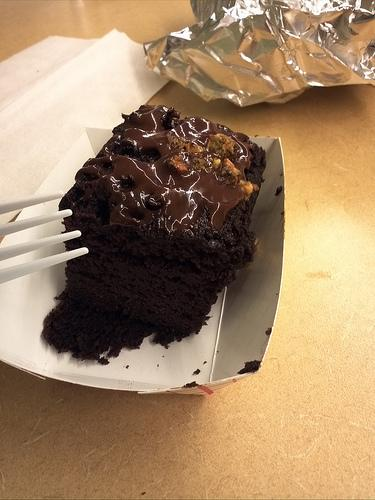What is the general sentiment or emotion that this image is likely to evoke in viewers? The image is likely to evoke feelings of indulgence, satisfaction, or temptation as the main focus is on a rich chocolate cake. Can you identify any materials used for the objects within this image? Yes, the fork is made of plastic, the dish is made of paper, and the crumpled object is made of aluminum foil. What is the main food item in the image? A piece of chocolate cake in a white paper dish. Explain the relationship between the objects near the chocolate cake. The objects near the chocolate cake, such as the white plastic fork, white napkin, and crumpled aluminum foil, are all items that are typically present during a casual dessert eating experience and complement the cake. Count the number of objects in the image that are made of plastic. There is only one plastic object, which is the white plastic fork. Is the presentation of the chocolate cake and its setting visually appealing? Explain your answer. Yes, the presentation is visually appealing with the chocolate cake as the main focus, surrounded by a clean fork, napkin, and crumpled aluminum foil that adds texture to the image. Describe any additional toppings or decorations present on the cake. There are nuts on top of the chocolate cake as a decorative and flavorful addition. Provide a brief description of the entire scene in the image. There is a piece of chocolate cake with nuts on a white paper dish next to a white plastic fork, crumpled aluminum foil, and white napkin on a beige countertop. Are there any inedible objects on the plate with the chocolate cake? No, there are no inedible objects on the plate with the chocolate cake. How many different objects are there with the cake? There are four other objects with the cake - a white plastic fork, crumpled aluminum foil, white napkin, and a beige countertop. Is there any aluminum foil in the image, and if yes, describe its state. Yes, there is crumpled aluminum foil. Do you see the sprinkles on top of the chocolate icing? They add such a nice pop of color to the cake. This instruction is misleading because there is no mention of sprinkles in the image information, only nuts. The viewer is led to look for colorful details that do not exist. Analyze the image and determine if there is an ongoing activity or event. No ongoing activity or event. List the materials of the fork and napkin. Fork is made of plastic, and the napkin is made of paper. Is there a diagram or blueprint present in the image? No Describe the objects on the countertop. A piece of chocolate cake in a tray, a white plastic fork, a crumpled piece of tinfoil, and a white napkin. What is the color and material of the tray holding the cake? White paper tray. Notice the ice cream scoop on top of the chocolate cake, melting slightly over the frosting. It looks so delicious, doesn't it? This instruction is misleading because there is no mention of ice cream in the image information, yet it asks the viewer to notice a non-existent object, making it seem like it's part of the dessert. Which dessert is in the tray: brownie or chocolate cake? Chocolate cake Observe the tiny blue teddy bear sitting on the counter by the white napkin. Isn't it adorable? This instruction is misleading because there is no mention of any teddy bear or toy in the image information. It falsely leads the viewer to look for a non-existent object. What are the main materials present on the countertop in the image? Cake, tinfoil, fork, napkin, and tray. Please locate the yellow mug with hot coffee on the table next to the crumpled piece of tin foil. It must be freshly brewed. This instruction is misleading because there is no mention of any mug or coffee in the image information. It creates a false sense of a complete scene by referring to a non-existing object. Identify the emotions of the people present in the image. Not applicable, no people present in the image. Choose the correct option for the base of the cake: gooey or thick? Option B: Thick Are there any people in the image, and if yes, what are their actions? No people in the image. Is there a fork in the image, and if so, what color and material is it? Yes, there is a white plastic fork. Can you notice the green apple placed next to the cake? It's quite ripe and juicy. This instruction is misleading because there is no mention of a green apple or any fruit in the given image information, yet it is asking the viewer to notice something that does not exist. Which type of cake is in the image? Chocolate cake. What is the cake topped with? Nuts and chocolate icing. Select the true statement about the cake: Option B: It contains nuts and chocolate icing. List four things that can be found on top of the chocolate cake. Nuts, chocolate icing, shiny topping, and gooey chocolate frosting. What is the color of the napkin? White Examine the fancy red napkin folded beside the basket of the brownie. It gives a touch of elegance to the dessert setting. This instruction is misleading because there is no mention of red napkin in the image information, only a white napkin. It falsely introduces a different color and style not present in the actual image. What color is the countertop? Beige Using the image, create a 5-step process for eating the cake. 1. Unfold the white napkin. Choose the correct option for the location of the cake: tabletop or inside a cabinet? Option B: Inside a cabinet 